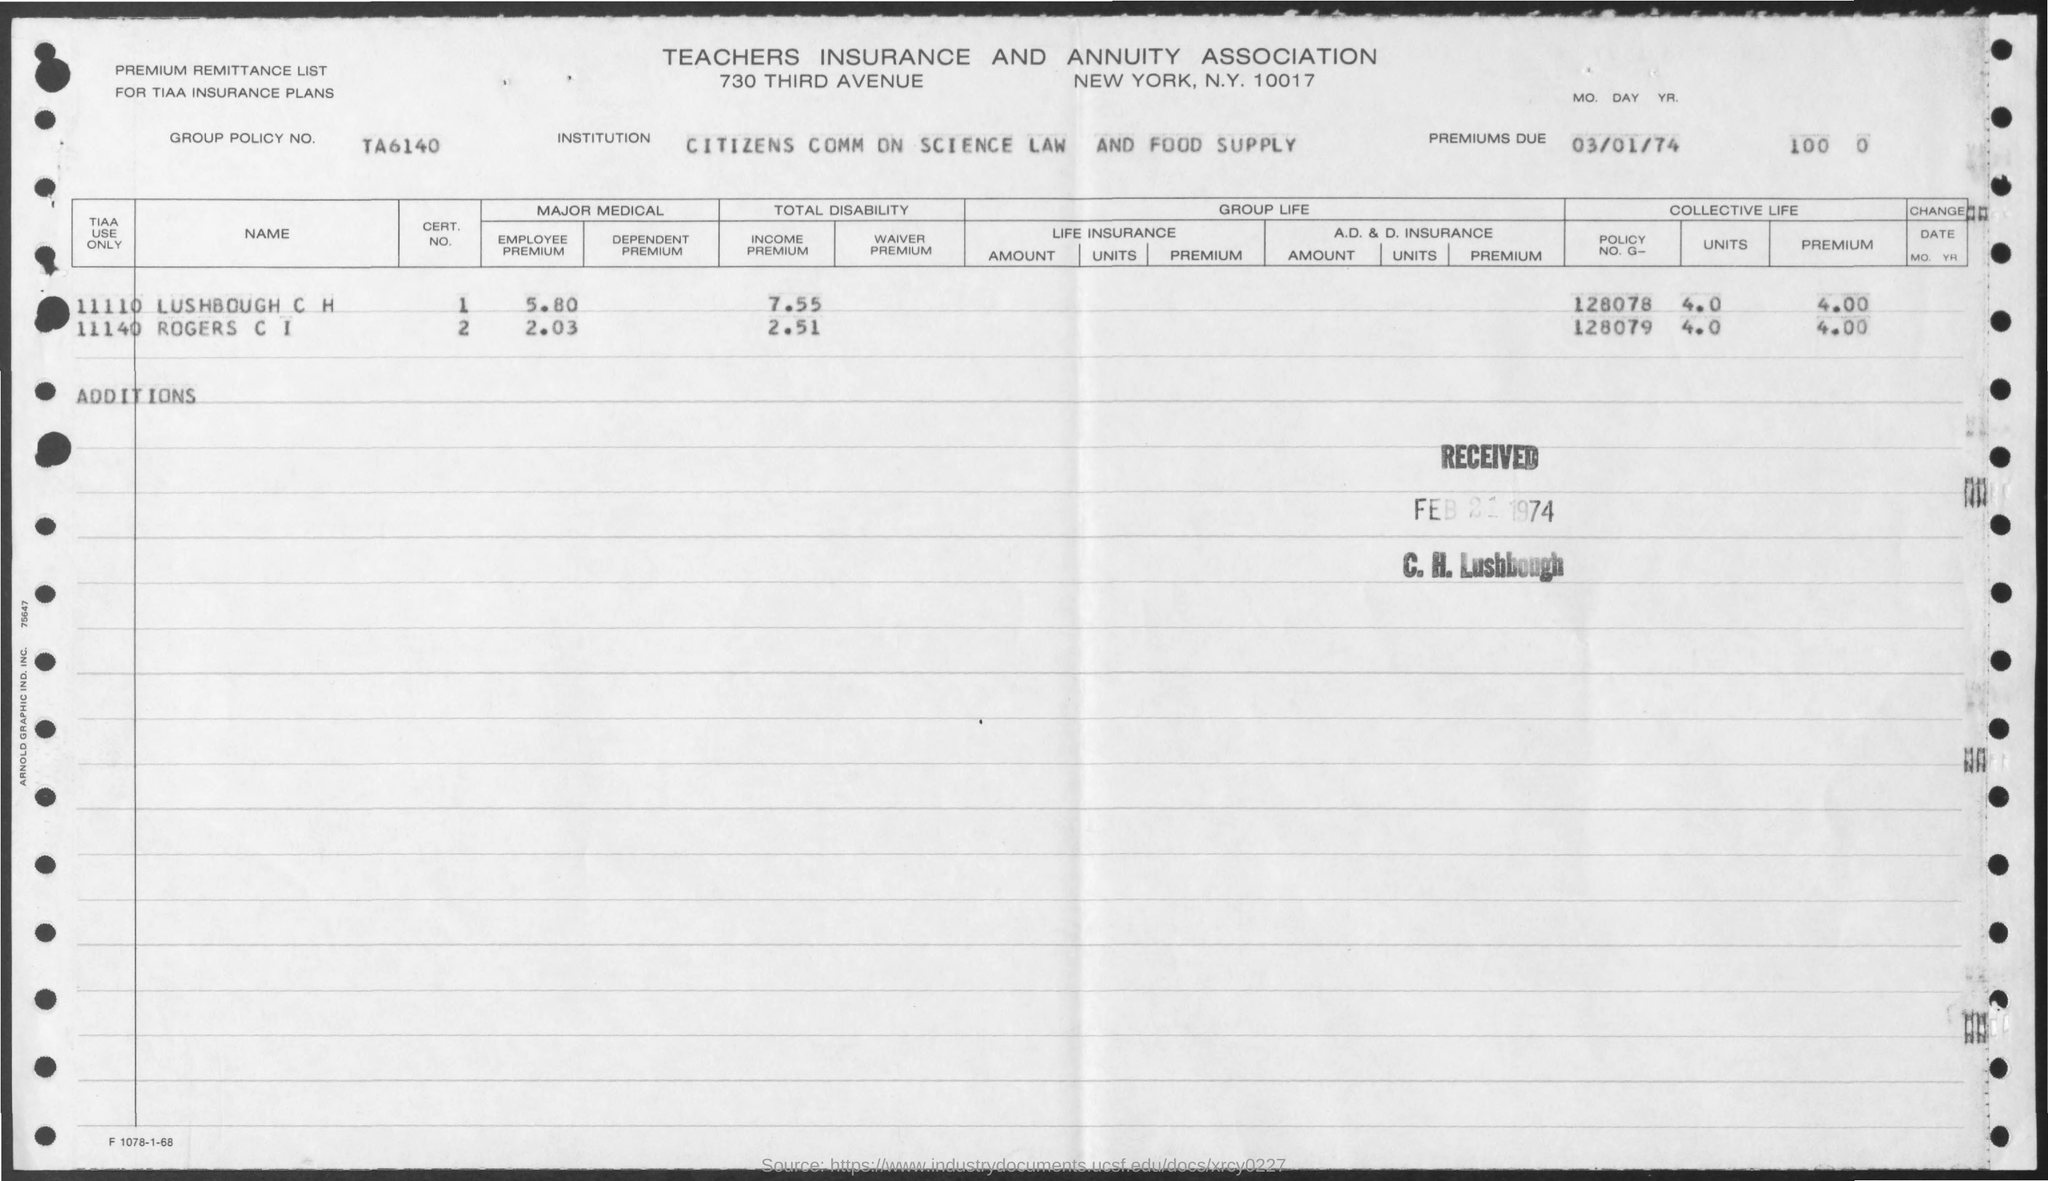Point out several critical features in this image. The policy number is G-128078 and it belongs to Lushbough C H. The premium due date was March 1, 1974. The form was received on February 21, 1974. The employee premium for Rogers Communications Inc. is 2.03. What is the income premium of Lushbough C H? The answer is 7.55. 